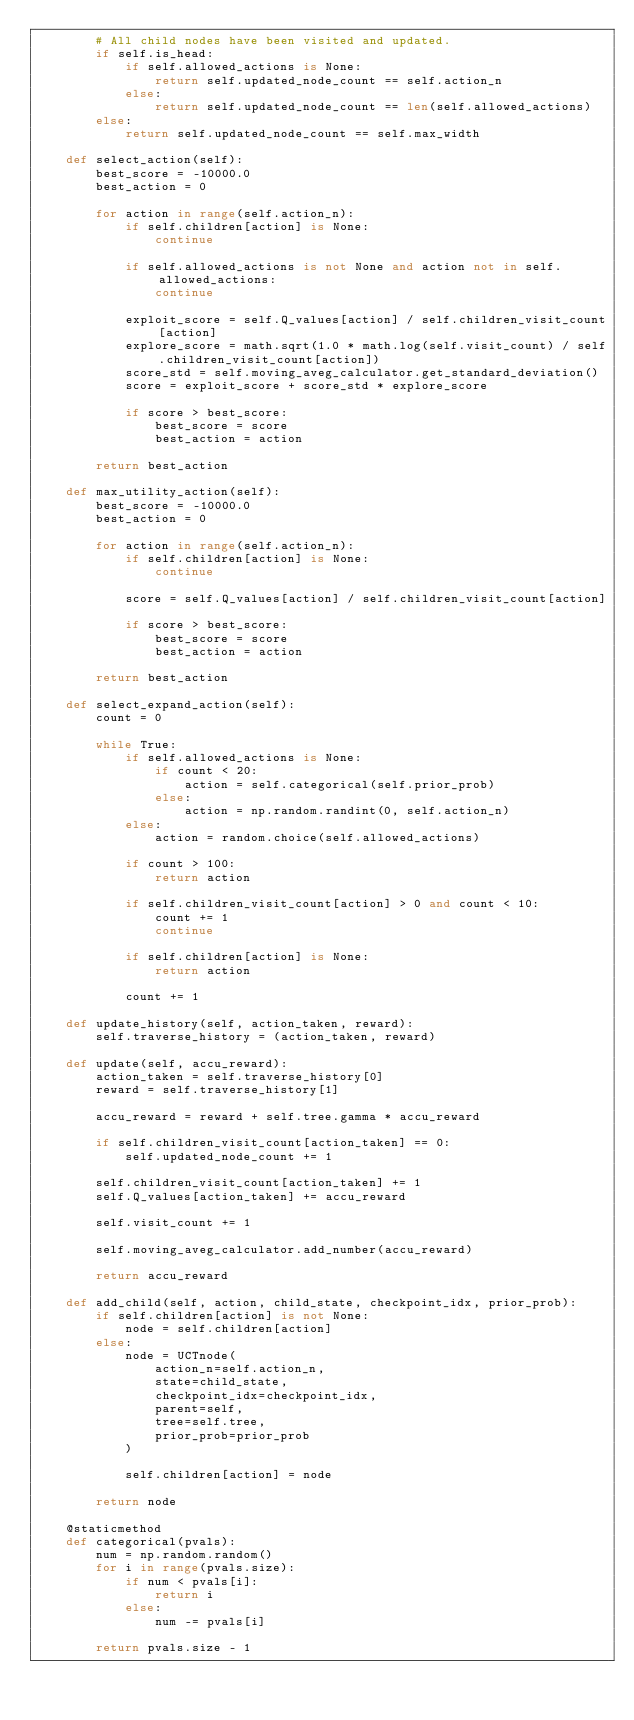<code> <loc_0><loc_0><loc_500><loc_500><_Python_>        # All child nodes have been visited and updated.
        if self.is_head:
            if self.allowed_actions is None:
                return self.updated_node_count == self.action_n
            else:
                return self.updated_node_count == len(self.allowed_actions)
        else:
            return self.updated_node_count == self.max_width

    def select_action(self):
        best_score = -10000.0
        best_action = 0

        for action in range(self.action_n):
            if self.children[action] is None:
                continue

            if self.allowed_actions is not None and action not in self.allowed_actions:
                continue

            exploit_score = self.Q_values[action] / self.children_visit_count[action]
            explore_score = math.sqrt(1.0 * math.log(self.visit_count) / self.children_visit_count[action])
            score_std = self.moving_aveg_calculator.get_standard_deviation()
            score = exploit_score + score_std * explore_score

            if score > best_score:
                best_score = score
                best_action = action

        return best_action

    def max_utility_action(self):
        best_score = -10000.0
        best_action = 0

        for action in range(self.action_n):
            if self.children[action] is None:
                continue

            score = self.Q_values[action] / self.children_visit_count[action]

            if score > best_score:
                best_score = score
                best_action = action

        return best_action

    def select_expand_action(self):
        count = 0

        while True:
            if self.allowed_actions is None:
                if count < 20:
                    action = self.categorical(self.prior_prob)
                else:
                    action = np.random.randint(0, self.action_n)
            else:
                action = random.choice(self.allowed_actions)

            if count > 100:
                return action

            if self.children_visit_count[action] > 0 and count < 10:
                count += 1
                continue

            if self.children[action] is None:
                return action

            count += 1

    def update_history(self, action_taken, reward):
        self.traverse_history = (action_taken, reward)

    def update(self, accu_reward):
        action_taken = self.traverse_history[0]
        reward = self.traverse_history[1]

        accu_reward = reward + self.tree.gamma * accu_reward

        if self.children_visit_count[action_taken] == 0:
            self.updated_node_count += 1

        self.children_visit_count[action_taken] += 1
        self.Q_values[action_taken] += accu_reward

        self.visit_count += 1

        self.moving_aveg_calculator.add_number(accu_reward)

        return accu_reward

    def add_child(self, action, child_state, checkpoint_idx, prior_prob):
        if self.children[action] is not None:
            node = self.children[action]
        else:
            node = UCTnode(
                action_n=self.action_n,
                state=child_state,
                checkpoint_idx=checkpoint_idx,
                parent=self,
                tree=self.tree,
                prior_prob=prior_prob
            )

            self.children[action] = node

        return node

    @staticmethod
    def categorical(pvals):
        num = np.random.random()
        for i in range(pvals.size):
            if num < pvals[i]:
                return i
            else:
                num -= pvals[i]

        return pvals.size - 1
</code> 